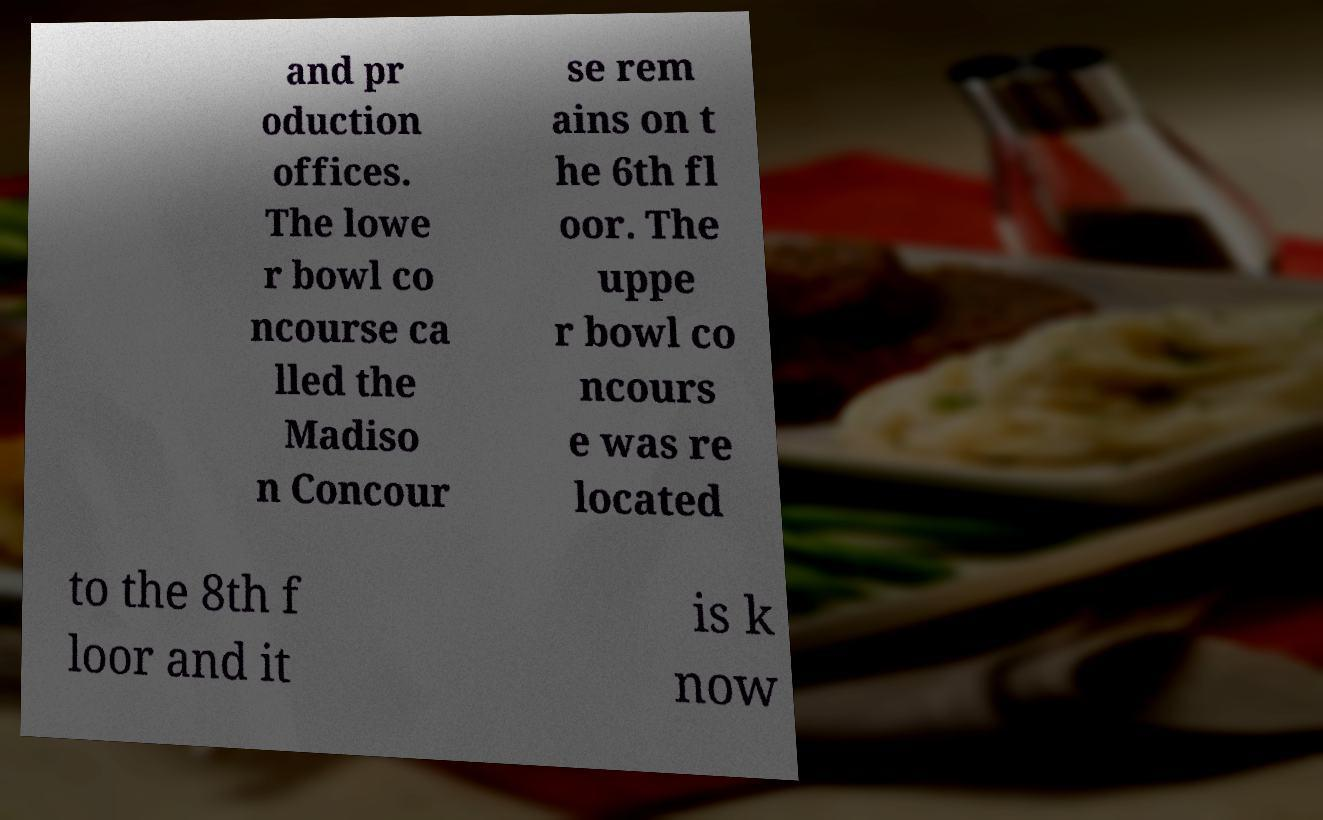I need the written content from this picture converted into text. Can you do that? and pr oduction offices. The lowe r bowl co ncourse ca lled the Madiso n Concour se rem ains on t he 6th fl oor. The uppe r bowl co ncours e was re located to the 8th f loor and it is k now 